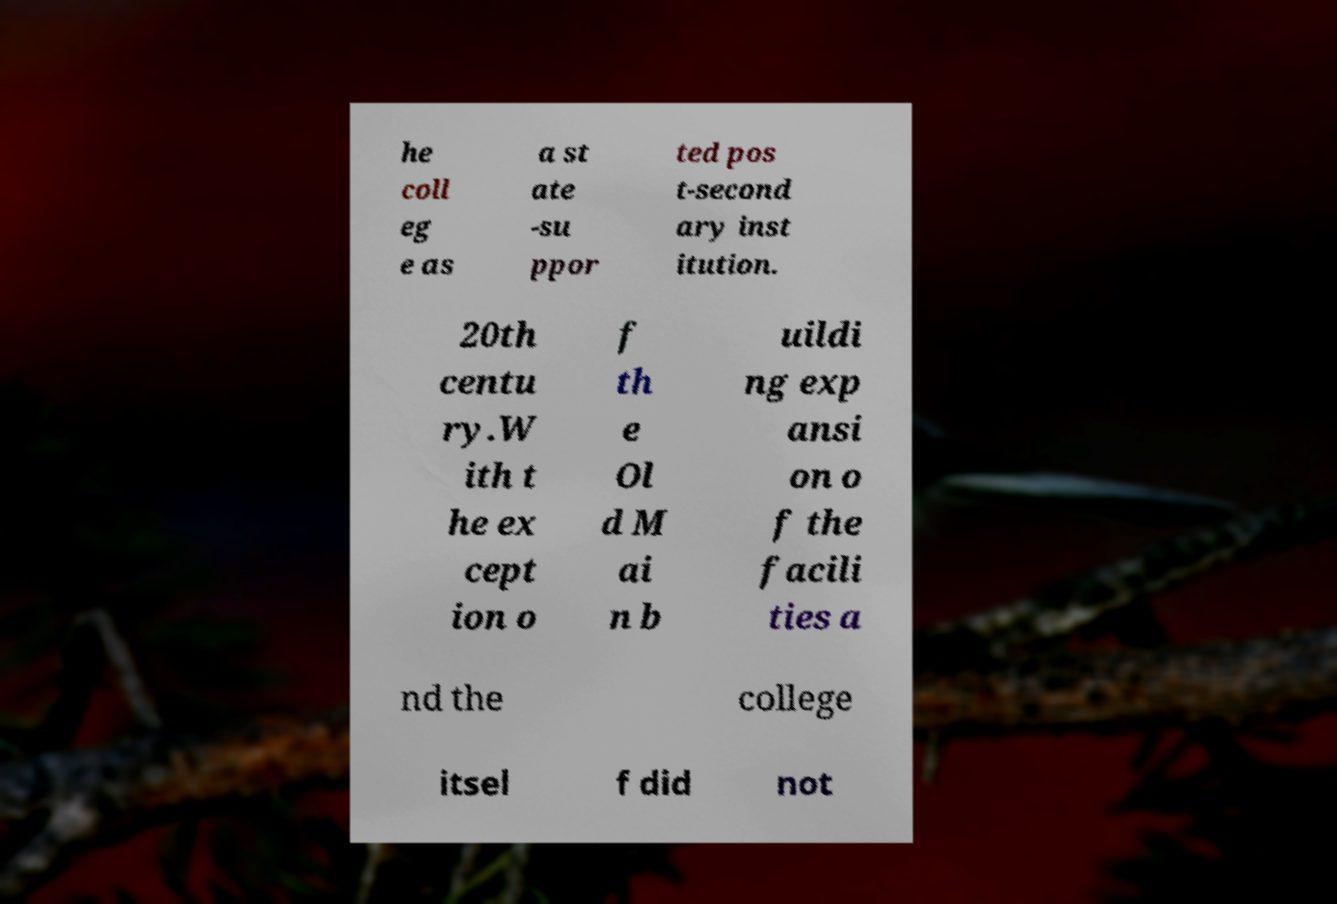Can you accurately transcribe the text from the provided image for me? he coll eg e as a st ate -su ppor ted pos t-second ary inst itution. 20th centu ry.W ith t he ex cept ion o f th e Ol d M ai n b uildi ng exp ansi on o f the facili ties a nd the college itsel f did not 